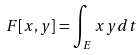<formula> <loc_0><loc_0><loc_500><loc_500>F [ x , y ] = \int _ { E } x y d t</formula> 